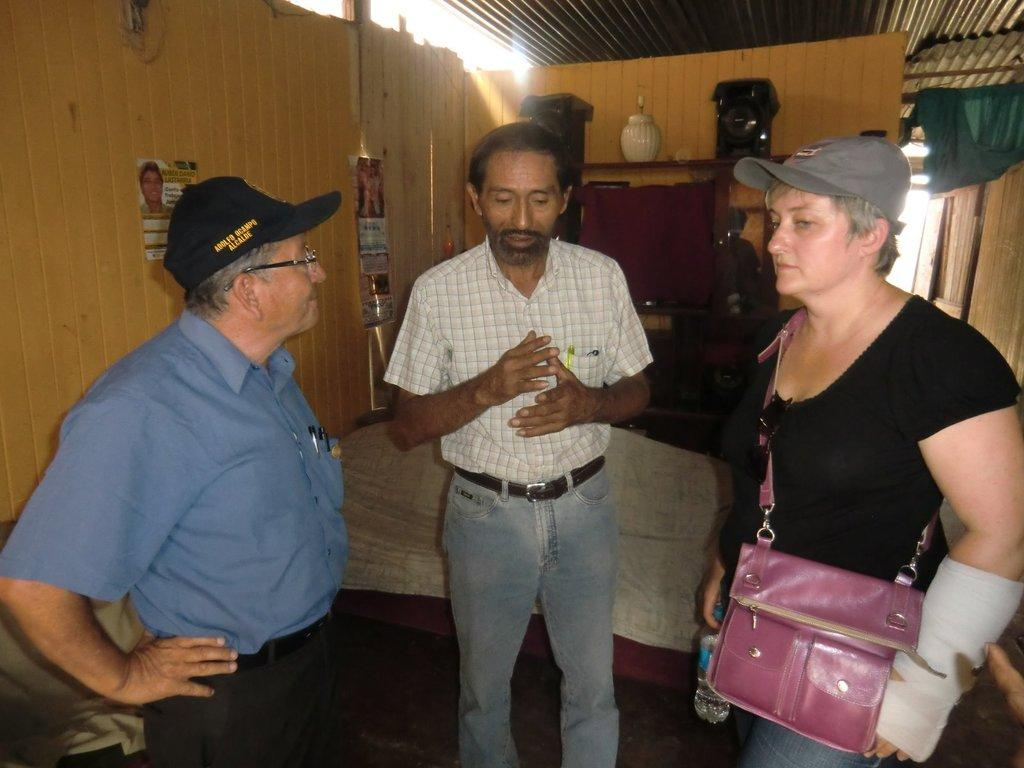What is happening in the image? There are people standing in the image. Can you describe any specific details about the people? A woman is wearing a pink-colored purse in the image. How does the sun contribute to the comfort of the people in the image? The image does not show the sun, so we cannot determine its contribution to the comfort of the people. 